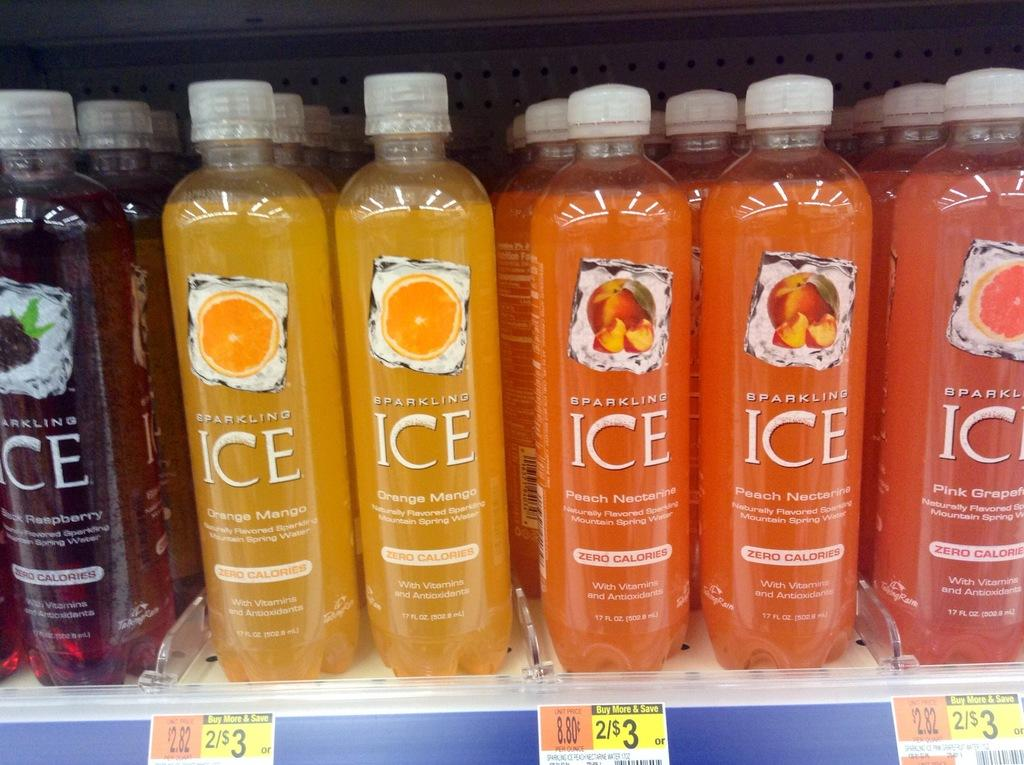<image>
Relay a brief, clear account of the picture shown. A display of ICE flavored Waters sits on a shelf in the store with a promotion of 2 for $3 